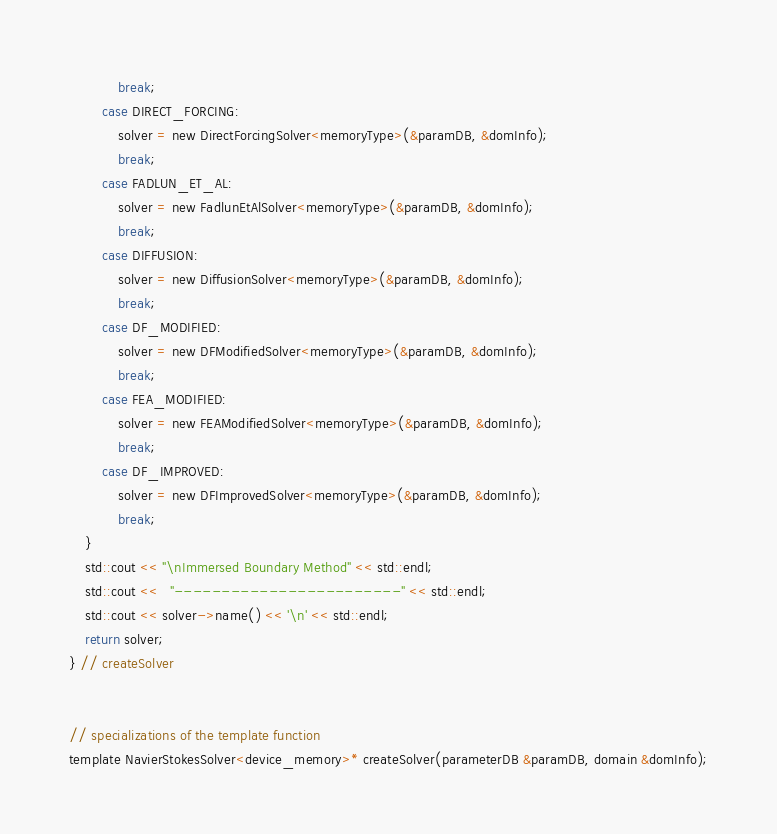<code> <loc_0><loc_0><loc_500><loc_500><_Cuda_>			break;
		case DIRECT_FORCING:
			solver = new DirectForcingSolver<memoryType>(&paramDB, &domInfo);
			break;
		case FADLUN_ET_AL:
			solver = new FadlunEtAlSolver<memoryType>(&paramDB, &domInfo);
			break;
		case DIFFUSION:
			solver = new DiffusionSolver<memoryType>(&paramDB, &domInfo);
			break;
		case DF_MODIFIED:
			solver = new DFModifiedSolver<memoryType>(&paramDB, &domInfo);
			break;
		case FEA_MODIFIED:
			solver = new FEAModifiedSolver<memoryType>(&paramDB, &domInfo);
			break;
		case DF_IMPROVED:
			solver = new DFImprovedSolver<memoryType>(&paramDB, &domInfo);
			break;
	}
	std::cout << "\nImmersed Boundary Method" << std::endl;
	std::cout <<   "------------------------" << std::endl;
	std::cout << solver->name() << '\n' << std::endl;
	return solver;
} // createSolver


// specializations of the template function
template NavierStokesSolver<device_memory>* createSolver(parameterDB &paramDB, domain &domInfo);
</code> 